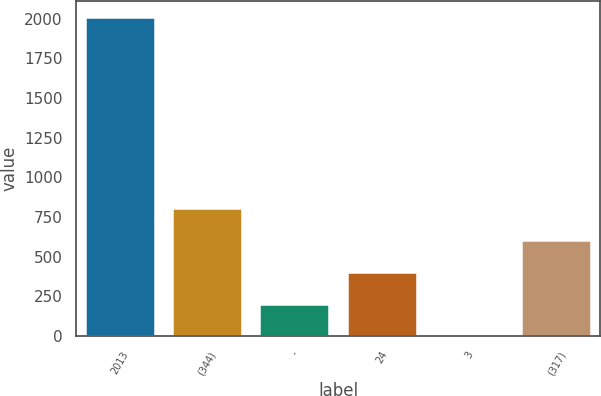Convert chart. <chart><loc_0><loc_0><loc_500><loc_500><bar_chart><fcel>2013<fcel>(344)<fcel>-<fcel>24<fcel>3<fcel>(317)<nl><fcel>2011<fcel>805<fcel>202<fcel>403<fcel>1<fcel>604<nl></chart> 